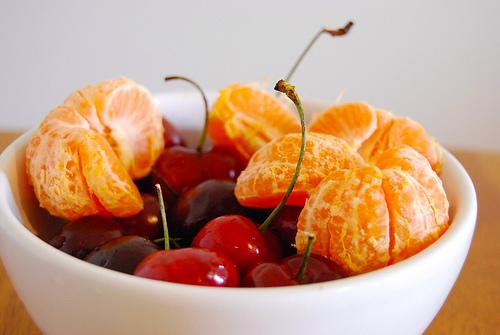What is contained in the red fruit that should not be ingested? Please explain your reasoning. seed. The fruit is a cherry and contains a pit in the center. 